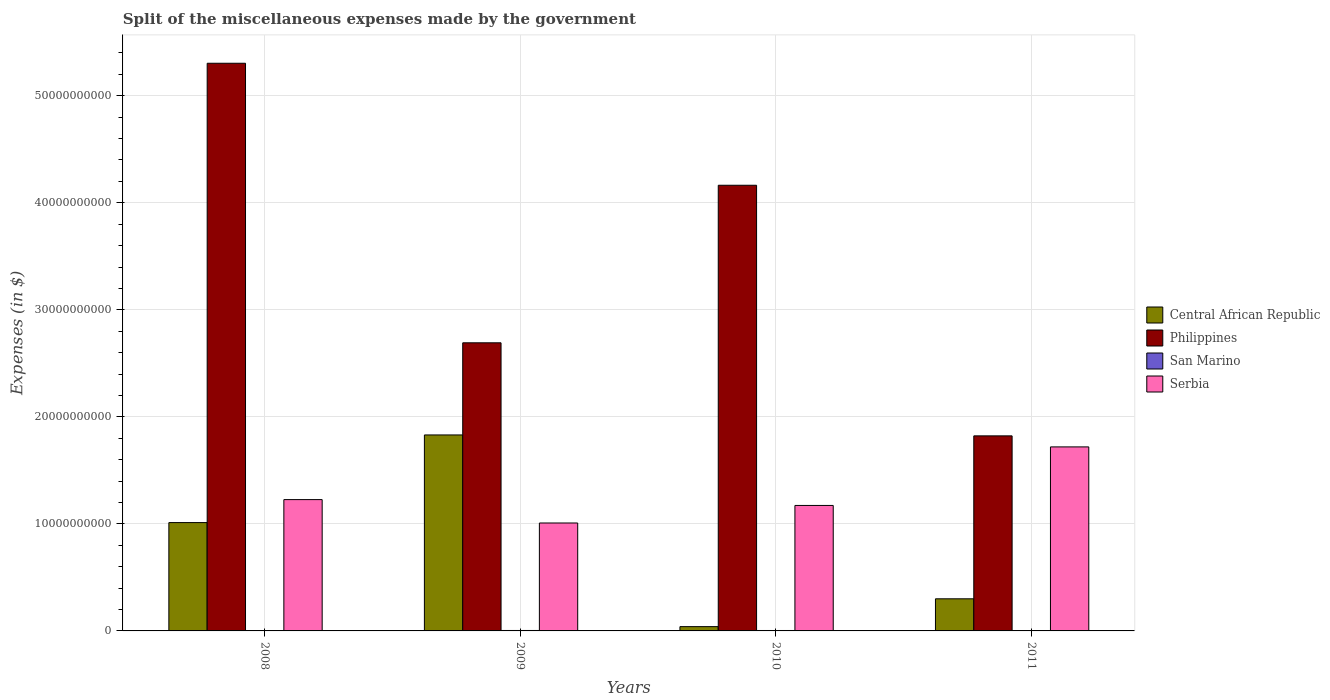How many bars are there on the 1st tick from the right?
Ensure brevity in your answer.  4. In how many cases, is the number of bars for a given year not equal to the number of legend labels?
Offer a terse response. 0. What is the miscellaneous expenses made by the government in Central African Republic in 2010?
Ensure brevity in your answer.  4.00e+08. Across all years, what is the maximum miscellaneous expenses made by the government in Philippines?
Your response must be concise. 5.30e+1. Across all years, what is the minimum miscellaneous expenses made by the government in Central African Republic?
Your answer should be compact. 4.00e+08. What is the total miscellaneous expenses made by the government in San Marino in the graph?
Give a very brief answer. 1.57e+08. What is the difference between the miscellaneous expenses made by the government in Philippines in 2010 and that in 2011?
Provide a short and direct response. 2.34e+1. What is the difference between the miscellaneous expenses made by the government in Serbia in 2008 and the miscellaneous expenses made by the government in Central African Republic in 2009?
Give a very brief answer. -6.04e+09. What is the average miscellaneous expenses made by the government in Philippines per year?
Your response must be concise. 3.50e+1. In the year 2010, what is the difference between the miscellaneous expenses made by the government in Serbia and miscellaneous expenses made by the government in Philippines?
Ensure brevity in your answer.  -2.99e+1. In how many years, is the miscellaneous expenses made by the government in Central African Republic greater than 4000000000 $?
Offer a terse response. 2. What is the ratio of the miscellaneous expenses made by the government in Serbia in 2008 to that in 2011?
Give a very brief answer. 0.71. What is the difference between the highest and the second highest miscellaneous expenses made by the government in Serbia?
Your answer should be compact. 4.92e+09. What is the difference between the highest and the lowest miscellaneous expenses made by the government in San Marino?
Offer a very short reply. 4.05e+06. Is the sum of the miscellaneous expenses made by the government in Philippines in 2008 and 2011 greater than the maximum miscellaneous expenses made by the government in Serbia across all years?
Give a very brief answer. Yes. Is it the case that in every year, the sum of the miscellaneous expenses made by the government in San Marino and miscellaneous expenses made by the government in Philippines is greater than the sum of miscellaneous expenses made by the government in Central African Republic and miscellaneous expenses made by the government in Serbia?
Give a very brief answer. No. What does the 3rd bar from the left in 2011 represents?
Provide a short and direct response. San Marino. What does the 2nd bar from the right in 2009 represents?
Make the answer very short. San Marino. How many bars are there?
Ensure brevity in your answer.  16. Are all the bars in the graph horizontal?
Provide a short and direct response. No. How many legend labels are there?
Ensure brevity in your answer.  4. How are the legend labels stacked?
Provide a short and direct response. Vertical. What is the title of the graph?
Your answer should be compact. Split of the miscellaneous expenses made by the government. Does "Namibia" appear as one of the legend labels in the graph?
Your response must be concise. No. What is the label or title of the Y-axis?
Offer a terse response. Expenses (in $). What is the Expenses (in $) in Central African Republic in 2008?
Your response must be concise. 1.01e+1. What is the Expenses (in $) in Philippines in 2008?
Your answer should be very brief. 5.30e+1. What is the Expenses (in $) in San Marino in 2008?
Give a very brief answer. 3.81e+07. What is the Expenses (in $) of Serbia in 2008?
Provide a succinct answer. 1.23e+1. What is the Expenses (in $) in Central African Republic in 2009?
Offer a very short reply. 1.83e+1. What is the Expenses (in $) of Philippines in 2009?
Offer a terse response. 2.69e+1. What is the Expenses (in $) in San Marino in 2009?
Make the answer very short. 4.16e+07. What is the Expenses (in $) of Serbia in 2009?
Ensure brevity in your answer.  1.01e+1. What is the Expenses (in $) in Central African Republic in 2010?
Your answer should be very brief. 4.00e+08. What is the Expenses (in $) of Philippines in 2010?
Your answer should be compact. 4.16e+1. What is the Expenses (in $) in San Marino in 2010?
Offer a very short reply. 4.00e+07. What is the Expenses (in $) of Serbia in 2010?
Make the answer very short. 1.17e+1. What is the Expenses (in $) of Central African Republic in 2011?
Give a very brief answer. 3.00e+09. What is the Expenses (in $) of Philippines in 2011?
Provide a short and direct response. 1.82e+1. What is the Expenses (in $) of San Marino in 2011?
Provide a succinct answer. 3.76e+07. What is the Expenses (in $) of Serbia in 2011?
Ensure brevity in your answer.  1.72e+1. Across all years, what is the maximum Expenses (in $) of Central African Republic?
Provide a succinct answer. 1.83e+1. Across all years, what is the maximum Expenses (in $) in Philippines?
Provide a short and direct response. 5.30e+1. Across all years, what is the maximum Expenses (in $) of San Marino?
Keep it short and to the point. 4.16e+07. Across all years, what is the maximum Expenses (in $) in Serbia?
Ensure brevity in your answer.  1.72e+1. Across all years, what is the minimum Expenses (in $) in Central African Republic?
Make the answer very short. 4.00e+08. Across all years, what is the minimum Expenses (in $) of Philippines?
Your response must be concise. 1.82e+1. Across all years, what is the minimum Expenses (in $) in San Marino?
Make the answer very short. 3.76e+07. Across all years, what is the minimum Expenses (in $) in Serbia?
Ensure brevity in your answer.  1.01e+1. What is the total Expenses (in $) in Central African Republic in the graph?
Provide a short and direct response. 3.18e+1. What is the total Expenses (in $) of Philippines in the graph?
Make the answer very short. 1.40e+11. What is the total Expenses (in $) in San Marino in the graph?
Your response must be concise. 1.57e+08. What is the total Expenses (in $) in Serbia in the graph?
Your answer should be very brief. 5.13e+1. What is the difference between the Expenses (in $) in Central African Republic in 2008 and that in 2009?
Provide a short and direct response. -8.19e+09. What is the difference between the Expenses (in $) of Philippines in 2008 and that in 2009?
Provide a succinct answer. 2.61e+1. What is the difference between the Expenses (in $) in San Marino in 2008 and that in 2009?
Your answer should be compact. -3.48e+06. What is the difference between the Expenses (in $) of Serbia in 2008 and that in 2009?
Offer a very short reply. 2.19e+09. What is the difference between the Expenses (in $) of Central African Republic in 2008 and that in 2010?
Make the answer very short. 9.72e+09. What is the difference between the Expenses (in $) in Philippines in 2008 and that in 2010?
Give a very brief answer. 1.14e+1. What is the difference between the Expenses (in $) in San Marino in 2008 and that in 2010?
Provide a short and direct response. -1.87e+06. What is the difference between the Expenses (in $) of Serbia in 2008 and that in 2010?
Give a very brief answer. 5.46e+08. What is the difference between the Expenses (in $) of Central African Republic in 2008 and that in 2011?
Offer a very short reply. 7.12e+09. What is the difference between the Expenses (in $) of Philippines in 2008 and that in 2011?
Your response must be concise. 3.48e+1. What is the difference between the Expenses (in $) of San Marino in 2008 and that in 2011?
Offer a terse response. 5.67e+05. What is the difference between the Expenses (in $) in Serbia in 2008 and that in 2011?
Provide a succinct answer. -4.92e+09. What is the difference between the Expenses (in $) of Central African Republic in 2009 and that in 2010?
Give a very brief answer. 1.79e+1. What is the difference between the Expenses (in $) of Philippines in 2009 and that in 2010?
Give a very brief answer. -1.47e+1. What is the difference between the Expenses (in $) of San Marino in 2009 and that in 2010?
Give a very brief answer. 1.61e+06. What is the difference between the Expenses (in $) of Serbia in 2009 and that in 2010?
Your response must be concise. -1.64e+09. What is the difference between the Expenses (in $) of Central African Republic in 2009 and that in 2011?
Provide a succinct answer. 1.53e+1. What is the difference between the Expenses (in $) in Philippines in 2009 and that in 2011?
Your answer should be compact. 8.69e+09. What is the difference between the Expenses (in $) in San Marino in 2009 and that in 2011?
Provide a succinct answer. 4.05e+06. What is the difference between the Expenses (in $) of Serbia in 2009 and that in 2011?
Provide a succinct answer. -7.11e+09. What is the difference between the Expenses (in $) of Central African Republic in 2010 and that in 2011?
Make the answer very short. -2.60e+09. What is the difference between the Expenses (in $) of Philippines in 2010 and that in 2011?
Your answer should be compact. 2.34e+1. What is the difference between the Expenses (in $) in San Marino in 2010 and that in 2011?
Provide a succinct answer. 2.44e+06. What is the difference between the Expenses (in $) of Serbia in 2010 and that in 2011?
Your response must be concise. -5.47e+09. What is the difference between the Expenses (in $) of Central African Republic in 2008 and the Expenses (in $) of Philippines in 2009?
Offer a very short reply. -1.68e+1. What is the difference between the Expenses (in $) of Central African Republic in 2008 and the Expenses (in $) of San Marino in 2009?
Give a very brief answer. 1.01e+1. What is the difference between the Expenses (in $) of Central African Republic in 2008 and the Expenses (in $) of Serbia in 2009?
Your answer should be compact. 3.84e+07. What is the difference between the Expenses (in $) in Philippines in 2008 and the Expenses (in $) in San Marino in 2009?
Give a very brief answer. 5.30e+1. What is the difference between the Expenses (in $) in Philippines in 2008 and the Expenses (in $) in Serbia in 2009?
Ensure brevity in your answer.  4.30e+1. What is the difference between the Expenses (in $) in San Marino in 2008 and the Expenses (in $) in Serbia in 2009?
Your answer should be very brief. -1.00e+1. What is the difference between the Expenses (in $) in Central African Republic in 2008 and the Expenses (in $) in Philippines in 2010?
Offer a very short reply. -3.15e+1. What is the difference between the Expenses (in $) in Central African Republic in 2008 and the Expenses (in $) in San Marino in 2010?
Keep it short and to the point. 1.01e+1. What is the difference between the Expenses (in $) in Central African Republic in 2008 and the Expenses (in $) in Serbia in 2010?
Your answer should be very brief. -1.60e+09. What is the difference between the Expenses (in $) in Philippines in 2008 and the Expenses (in $) in San Marino in 2010?
Provide a short and direct response. 5.30e+1. What is the difference between the Expenses (in $) of Philippines in 2008 and the Expenses (in $) of Serbia in 2010?
Ensure brevity in your answer.  4.13e+1. What is the difference between the Expenses (in $) in San Marino in 2008 and the Expenses (in $) in Serbia in 2010?
Your answer should be compact. -1.17e+1. What is the difference between the Expenses (in $) in Central African Republic in 2008 and the Expenses (in $) in Philippines in 2011?
Give a very brief answer. -8.10e+09. What is the difference between the Expenses (in $) in Central African Republic in 2008 and the Expenses (in $) in San Marino in 2011?
Your response must be concise. 1.01e+1. What is the difference between the Expenses (in $) of Central African Republic in 2008 and the Expenses (in $) of Serbia in 2011?
Offer a terse response. -7.07e+09. What is the difference between the Expenses (in $) of Philippines in 2008 and the Expenses (in $) of San Marino in 2011?
Your response must be concise. 5.30e+1. What is the difference between the Expenses (in $) in Philippines in 2008 and the Expenses (in $) in Serbia in 2011?
Provide a short and direct response. 3.58e+1. What is the difference between the Expenses (in $) of San Marino in 2008 and the Expenses (in $) of Serbia in 2011?
Keep it short and to the point. -1.72e+1. What is the difference between the Expenses (in $) of Central African Republic in 2009 and the Expenses (in $) of Philippines in 2010?
Make the answer very short. -2.33e+1. What is the difference between the Expenses (in $) of Central African Republic in 2009 and the Expenses (in $) of San Marino in 2010?
Make the answer very short. 1.83e+1. What is the difference between the Expenses (in $) in Central African Republic in 2009 and the Expenses (in $) in Serbia in 2010?
Your answer should be compact. 6.59e+09. What is the difference between the Expenses (in $) in Philippines in 2009 and the Expenses (in $) in San Marino in 2010?
Keep it short and to the point. 2.69e+1. What is the difference between the Expenses (in $) in Philippines in 2009 and the Expenses (in $) in Serbia in 2010?
Offer a terse response. 1.52e+1. What is the difference between the Expenses (in $) of San Marino in 2009 and the Expenses (in $) of Serbia in 2010?
Ensure brevity in your answer.  -1.17e+1. What is the difference between the Expenses (in $) of Central African Republic in 2009 and the Expenses (in $) of Philippines in 2011?
Offer a very short reply. 8.48e+07. What is the difference between the Expenses (in $) of Central African Republic in 2009 and the Expenses (in $) of San Marino in 2011?
Make the answer very short. 1.83e+1. What is the difference between the Expenses (in $) of Central African Republic in 2009 and the Expenses (in $) of Serbia in 2011?
Your answer should be compact. 1.12e+09. What is the difference between the Expenses (in $) in Philippines in 2009 and the Expenses (in $) in San Marino in 2011?
Give a very brief answer. 2.69e+1. What is the difference between the Expenses (in $) of Philippines in 2009 and the Expenses (in $) of Serbia in 2011?
Your answer should be very brief. 9.73e+09. What is the difference between the Expenses (in $) of San Marino in 2009 and the Expenses (in $) of Serbia in 2011?
Offer a terse response. -1.72e+1. What is the difference between the Expenses (in $) in Central African Republic in 2010 and the Expenses (in $) in Philippines in 2011?
Provide a short and direct response. -1.78e+1. What is the difference between the Expenses (in $) in Central African Republic in 2010 and the Expenses (in $) in San Marino in 2011?
Offer a terse response. 3.62e+08. What is the difference between the Expenses (in $) of Central African Republic in 2010 and the Expenses (in $) of Serbia in 2011?
Offer a terse response. -1.68e+1. What is the difference between the Expenses (in $) of Philippines in 2010 and the Expenses (in $) of San Marino in 2011?
Provide a succinct answer. 4.16e+1. What is the difference between the Expenses (in $) of Philippines in 2010 and the Expenses (in $) of Serbia in 2011?
Your response must be concise. 2.44e+1. What is the difference between the Expenses (in $) of San Marino in 2010 and the Expenses (in $) of Serbia in 2011?
Your answer should be very brief. -1.72e+1. What is the average Expenses (in $) of Central African Republic per year?
Your response must be concise. 7.96e+09. What is the average Expenses (in $) of Philippines per year?
Your answer should be compact. 3.50e+1. What is the average Expenses (in $) in San Marino per year?
Offer a terse response. 3.93e+07. What is the average Expenses (in $) of Serbia per year?
Your answer should be compact. 1.28e+1. In the year 2008, what is the difference between the Expenses (in $) in Central African Republic and Expenses (in $) in Philippines?
Offer a very short reply. -4.29e+1. In the year 2008, what is the difference between the Expenses (in $) of Central African Republic and Expenses (in $) of San Marino?
Your answer should be very brief. 1.01e+1. In the year 2008, what is the difference between the Expenses (in $) of Central African Republic and Expenses (in $) of Serbia?
Your answer should be very brief. -2.15e+09. In the year 2008, what is the difference between the Expenses (in $) of Philippines and Expenses (in $) of San Marino?
Your answer should be compact. 5.30e+1. In the year 2008, what is the difference between the Expenses (in $) of Philippines and Expenses (in $) of Serbia?
Provide a short and direct response. 4.08e+1. In the year 2008, what is the difference between the Expenses (in $) in San Marino and Expenses (in $) in Serbia?
Your response must be concise. -1.22e+1. In the year 2009, what is the difference between the Expenses (in $) in Central African Republic and Expenses (in $) in Philippines?
Provide a short and direct response. -8.61e+09. In the year 2009, what is the difference between the Expenses (in $) in Central African Republic and Expenses (in $) in San Marino?
Give a very brief answer. 1.83e+1. In the year 2009, what is the difference between the Expenses (in $) in Central African Republic and Expenses (in $) in Serbia?
Your answer should be compact. 8.23e+09. In the year 2009, what is the difference between the Expenses (in $) in Philippines and Expenses (in $) in San Marino?
Offer a terse response. 2.69e+1. In the year 2009, what is the difference between the Expenses (in $) of Philippines and Expenses (in $) of Serbia?
Offer a very short reply. 1.68e+1. In the year 2009, what is the difference between the Expenses (in $) of San Marino and Expenses (in $) of Serbia?
Provide a succinct answer. -1.00e+1. In the year 2010, what is the difference between the Expenses (in $) in Central African Republic and Expenses (in $) in Philippines?
Give a very brief answer. -4.12e+1. In the year 2010, what is the difference between the Expenses (in $) in Central African Republic and Expenses (in $) in San Marino?
Provide a succinct answer. 3.60e+08. In the year 2010, what is the difference between the Expenses (in $) in Central African Republic and Expenses (in $) in Serbia?
Ensure brevity in your answer.  -1.13e+1. In the year 2010, what is the difference between the Expenses (in $) of Philippines and Expenses (in $) of San Marino?
Your answer should be compact. 4.16e+1. In the year 2010, what is the difference between the Expenses (in $) in Philippines and Expenses (in $) in Serbia?
Offer a very short reply. 2.99e+1. In the year 2010, what is the difference between the Expenses (in $) of San Marino and Expenses (in $) of Serbia?
Provide a short and direct response. -1.17e+1. In the year 2011, what is the difference between the Expenses (in $) of Central African Republic and Expenses (in $) of Philippines?
Keep it short and to the point. -1.52e+1. In the year 2011, what is the difference between the Expenses (in $) of Central African Republic and Expenses (in $) of San Marino?
Give a very brief answer. 2.96e+09. In the year 2011, what is the difference between the Expenses (in $) in Central African Republic and Expenses (in $) in Serbia?
Your answer should be very brief. -1.42e+1. In the year 2011, what is the difference between the Expenses (in $) in Philippines and Expenses (in $) in San Marino?
Make the answer very short. 1.82e+1. In the year 2011, what is the difference between the Expenses (in $) in Philippines and Expenses (in $) in Serbia?
Ensure brevity in your answer.  1.03e+09. In the year 2011, what is the difference between the Expenses (in $) of San Marino and Expenses (in $) of Serbia?
Make the answer very short. -1.72e+1. What is the ratio of the Expenses (in $) in Central African Republic in 2008 to that in 2009?
Your answer should be compact. 0.55. What is the ratio of the Expenses (in $) in Philippines in 2008 to that in 2009?
Keep it short and to the point. 1.97. What is the ratio of the Expenses (in $) of San Marino in 2008 to that in 2009?
Your answer should be compact. 0.92. What is the ratio of the Expenses (in $) of Serbia in 2008 to that in 2009?
Your answer should be very brief. 1.22. What is the ratio of the Expenses (in $) of Central African Republic in 2008 to that in 2010?
Make the answer very short. 25.3. What is the ratio of the Expenses (in $) of Philippines in 2008 to that in 2010?
Offer a very short reply. 1.27. What is the ratio of the Expenses (in $) in San Marino in 2008 to that in 2010?
Your response must be concise. 0.95. What is the ratio of the Expenses (in $) of Serbia in 2008 to that in 2010?
Ensure brevity in your answer.  1.05. What is the ratio of the Expenses (in $) in Central African Republic in 2008 to that in 2011?
Ensure brevity in your answer.  3.37. What is the ratio of the Expenses (in $) of Philippines in 2008 to that in 2011?
Offer a very short reply. 2.91. What is the ratio of the Expenses (in $) in San Marino in 2008 to that in 2011?
Ensure brevity in your answer.  1.02. What is the ratio of the Expenses (in $) in Serbia in 2008 to that in 2011?
Offer a very short reply. 0.71. What is the ratio of the Expenses (in $) in Central African Republic in 2009 to that in 2010?
Ensure brevity in your answer.  45.77. What is the ratio of the Expenses (in $) in Philippines in 2009 to that in 2010?
Provide a succinct answer. 0.65. What is the ratio of the Expenses (in $) in San Marino in 2009 to that in 2010?
Offer a very short reply. 1.04. What is the ratio of the Expenses (in $) in Serbia in 2009 to that in 2010?
Make the answer very short. 0.86. What is the ratio of the Expenses (in $) in Central African Republic in 2009 to that in 2011?
Keep it short and to the point. 6.1. What is the ratio of the Expenses (in $) in Philippines in 2009 to that in 2011?
Your answer should be compact. 1.48. What is the ratio of the Expenses (in $) of San Marino in 2009 to that in 2011?
Keep it short and to the point. 1.11. What is the ratio of the Expenses (in $) in Serbia in 2009 to that in 2011?
Ensure brevity in your answer.  0.59. What is the ratio of the Expenses (in $) of Central African Republic in 2010 to that in 2011?
Offer a terse response. 0.13. What is the ratio of the Expenses (in $) in Philippines in 2010 to that in 2011?
Ensure brevity in your answer.  2.28. What is the ratio of the Expenses (in $) in San Marino in 2010 to that in 2011?
Offer a very short reply. 1.06. What is the ratio of the Expenses (in $) in Serbia in 2010 to that in 2011?
Ensure brevity in your answer.  0.68. What is the difference between the highest and the second highest Expenses (in $) in Central African Republic?
Give a very brief answer. 8.19e+09. What is the difference between the highest and the second highest Expenses (in $) of Philippines?
Offer a very short reply. 1.14e+1. What is the difference between the highest and the second highest Expenses (in $) in San Marino?
Your response must be concise. 1.61e+06. What is the difference between the highest and the second highest Expenses (in $) of Serbia?
Provide a succinct answer. 4.92e+09. What is the difference between the highest and the lowest Expenses (in $) in Central African Republic?
Provide a short and direct response. 1.79e+1. What is the difference between the highest and the lowest Expenses (in $) in Philippines?
Your answer should be compact. 3.48e+1. What is the difference between the highest and the lowest Expenses (in $) of San Marino?
Make the answer very short. 4.05e+06. What is the difference between the highest and the lowest Expenses (in $) in Serbia?
Provide a short and direct response. 7.11e+09. 